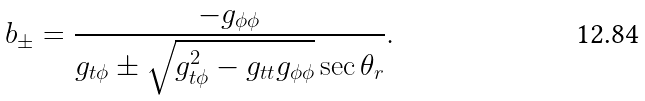<formula> <loc_0><loc_0><loc_500><loc_500>b _ { \pm } = \frac { - g _ { \phi \phi } } { g _ { t \phi } \pm \sqrt { g _ { t \phi } ^ { 2 } - g _ { t t } g _ { \phi \phi } } \sec \theta _ { r } } .</formula> 